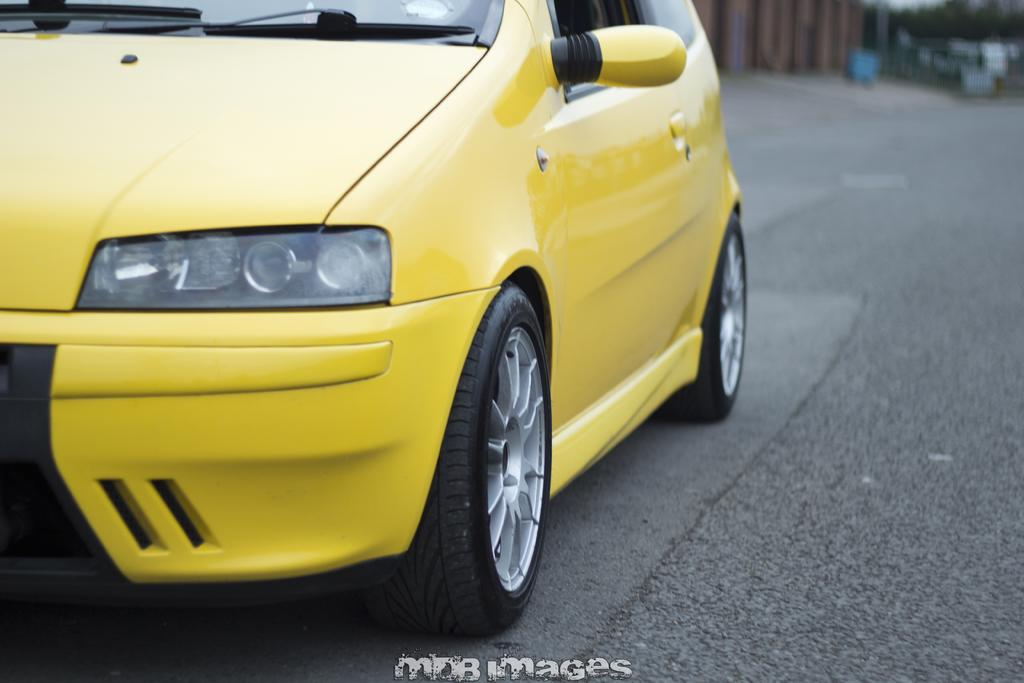What color is the car in the image? The car in the image is yellow. Where is the car located in the image? The car is on the road in the image. Is there any text present in the image? Yes, there is some text at the bottom of the image. What type of machine is being used to apply glue to the table in the image? There is no machine or table present in the image, and no glue application is depicted. 